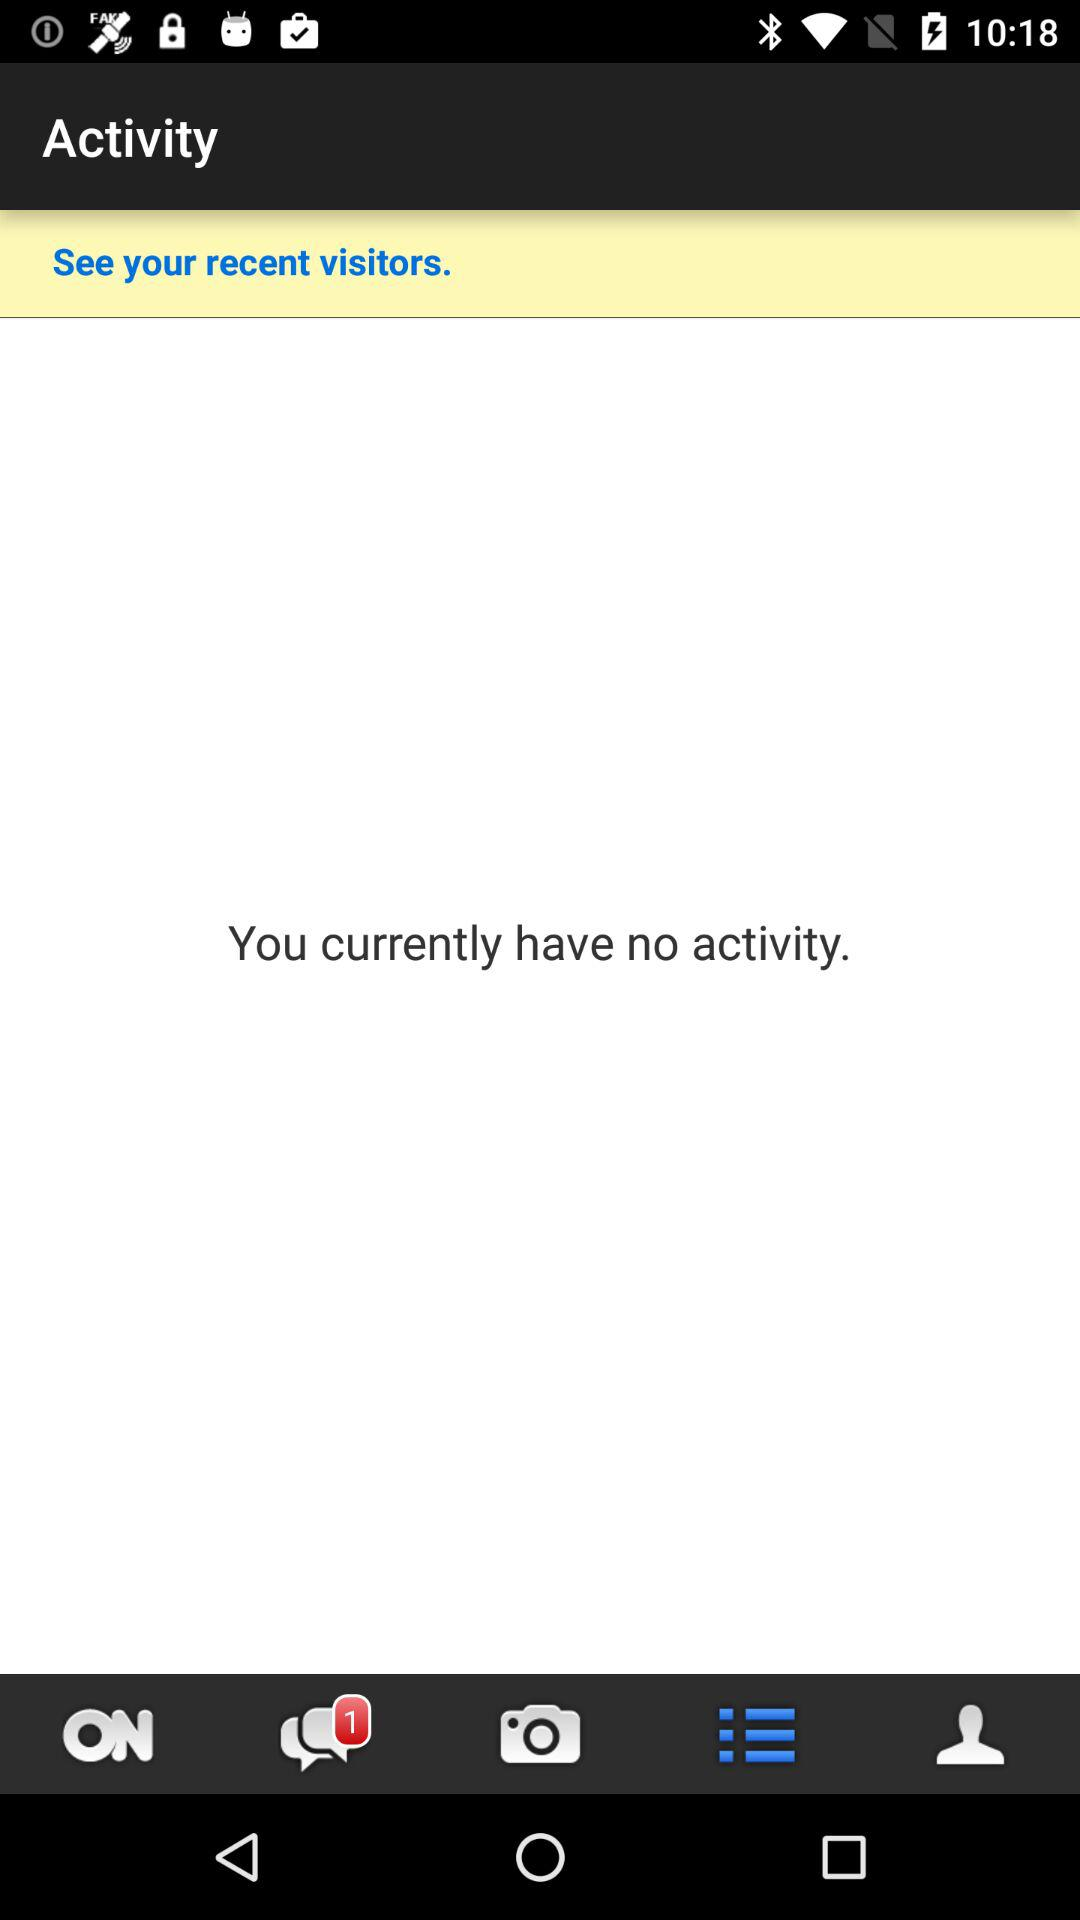How many more notifications are there than recent visitors?
Answer the question using a single word or phrase. 1 